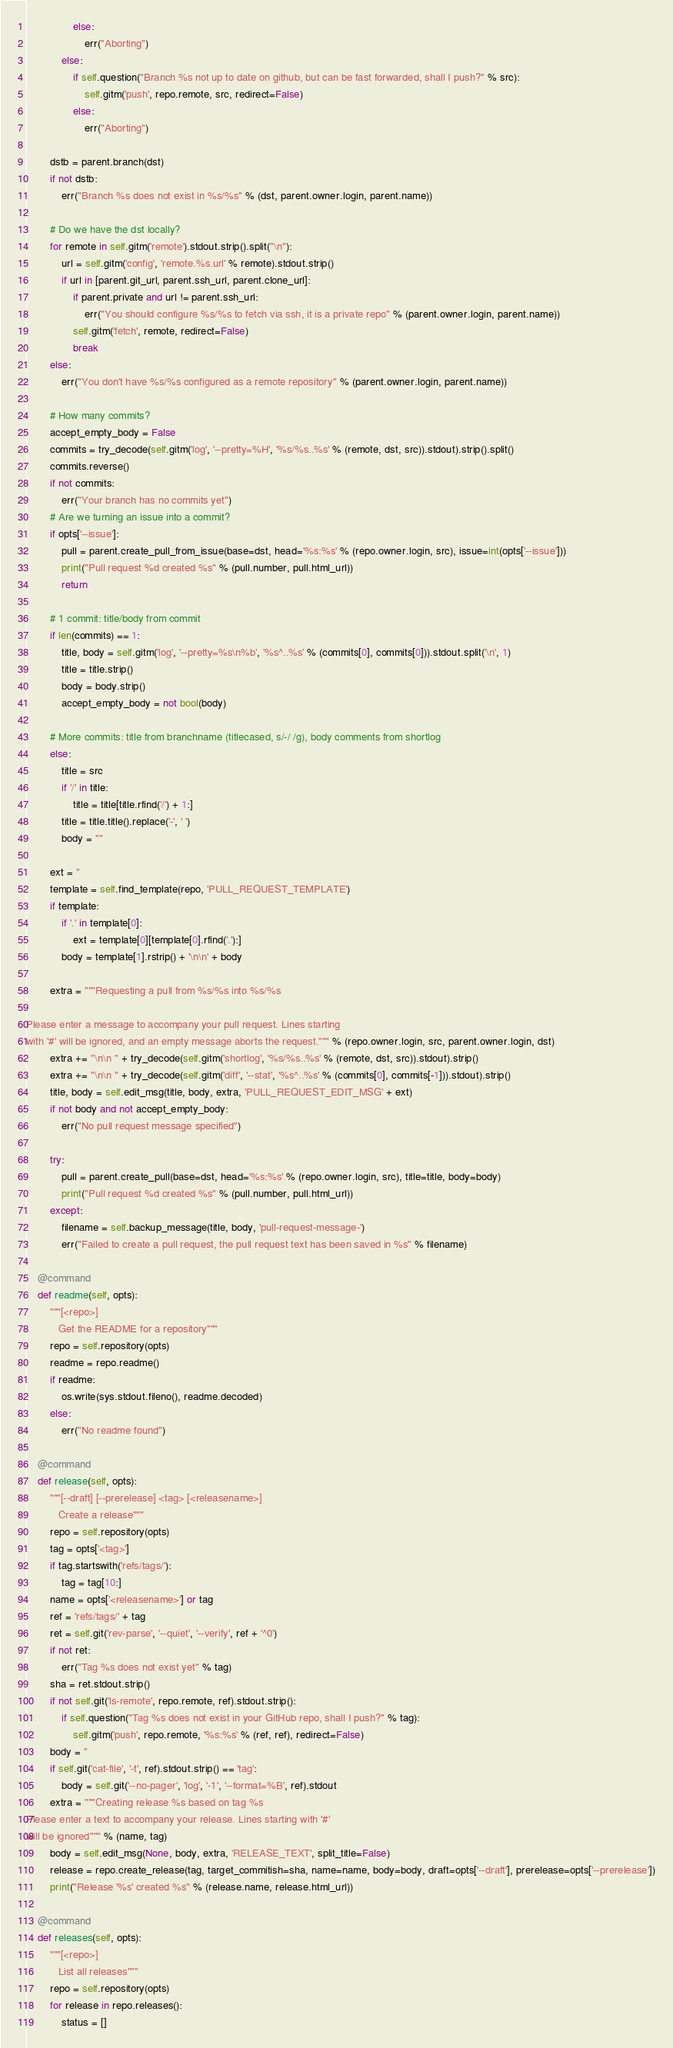<code> <loc_0><loc_0><loc_500><loc_500><_Python_>                else:
                    err("Aborting")
            else:
                if self.question("Branch %s not up to date on github, but can be fast forwarded, shall I push?" % src):
                    self.gitm('push', repo.remote, src, redirect=False)
                else:
                    err("Aborting")

        dstb = parent.branch(dst)
        if not dstb:
            err("Branch %s does not exist in %s/%s" % (dst, parent.owner.login, parent.name))

        # Do we have the dst locally?
        for remote in self.gitm('remote').stdout.strip().split("\n"):
            url = self.gitm('config', 'remote.%s.url' % remote).stdout.strip()
            if url in [parent.git_url, parent.ssh_url, parent.clone_url]:
                if parent.private and url != parent.ssh_url:
                    err("You should configure %s/%s to fetch via ssh, it is a private repo" % (parent.owner.login, parent.name))
                self.gitm('fetch', remote, redirect=False)
                break
        else:
            err("You don't have %s/%s configured as a remote repository" % (parent.owner.login, parent.name))

        # How many commits?
        accept_empty_body = False
        commits = try_decode(self.gitm('log', '--pretty=%H', '%s/%s..%s' % (remote, dst, src)).stdout).strip().split()
        commits.reverse()
        if not commits:
            err("Your branch has no commits yet")
        # Are we turning an issue into a commit?
        if opts['--issue']:
            pull = parent.create_pull_from_issue(base=dst, head='%s:%s' % (repo.owner.login, src), issue=int(opts['--issue']))
            print("Pull request %d created %s" % (pull.number, pull.html_url))
            return

        # 1 commit: title/body from commit
        if len(commits) == 1:
            title, body = self.gitm('log', '--pretty=%s\n%b', '%s^..%s' % (commits[0], commits[0])).stdout.split('\n', 1)
            title = title.strip()
            body = body.strip()
            accept_empty_body = not bool(body)

        # More commits: title from branchname (titlecased, s/-/ /g), body comments from shortlog
        else:
            title = src
            if '/' in title:
                title = title[title.rfind('/') + 1:]
            title = title.title().replace('-', ' ')
            body = ""

        ext = ''
        template = self.find_template(repo, 'PULL_REQUEST_TEMPLATE')
        if template:
            if '.' in template[0]:
                ext = template[0][template[0].rfind('.'):]
            body = template[1].rstrip() + '\n\n' + body

        extra = """Requesting a pull from %s/%s into %s/%s

Please enter a message to accompany your pull request. Lines starting
with '#' will be ignored, and an empty message aborts the request.""" % (repo.owner.login, src, parent.owner.login, dst)
        extra += "\n\n " + try_decode(self.gitm('shortlog', '%s/%s..%s' % (remote, dst, src)).stdout).strip()
        extra += "\n\n " + try_decode(self.gitm('diff', '--stat', '%s^..%s' % (commits[0], commits[-1])).stdout).strip()
        title, body = self.edit_msg(title, body, extra, 'PULL_REQUEST_EDIT_MSG' + ext)
        if not body and not accept_empty_body:
            err("No pull request message specified")

        try:
            pull = parent.create_pull(base=dst, head='%s:%s' % (repo.owner.login, src), title=title, body=body)
            print("Pull request %d created %s" % (pull.number, pull.html_url))
        except:
            filename = self.backup_message(title, body, 'pull-request-message-')
            err("Failed to create a pull request, the pull request text has been saved in %s" % filename)

    @command
    def readme(self, opts):
        """[<repo>]
           Get the README for a repository"""
        repo = self.repository(opts)
        readme = repo.readme()
        if readme:
            os.write(sys.stdout.fileno(), readme.decoded)
        else:
            err("No readme found")

    @command
    def release(self, opts):
        """[--draft] [--prerelease] <tag> [<releasename>]
           Create a release"""
        repo = self.repository(opts)
        tag = opts['<tag>']
        if tag.startswith('refs/tags/'):
            tag = tag[10:]
        name = opts['<releasename>'] or tag
        ref = 'refs/tags/' + tag
        ret = self.git('rev-parse', '--quiet', '--verify', ref + '^0')
        if not ret:
            err("Tag %s does not exist yet" % tag)
        sha = ret.stdout.strip()
        if not self.git('ls-remote', repo.remote, ref).stdout.strip():
            if self.question("Tag %s does not exist in your GitHub repo, shall I push?" % tag):
                self.gitm('push', repo.remote, '%s:%s' % (ref, ref), redirect=False)
        body = ''
        if self.git('cat-file', '-t', ref).stdout.strip() == 'tag':
            body = self.git('--no-pager', 'log', '-1', '--format=%B', ref).stdout
        extra = """Creating release %s based on tag %s
Please enter a text to accompany your release. Lines starting with '#'
will be ignored""" % (name, tag)
        body = self.edit_msg(None, body, extra, 'RELEASE_TEXT', split_title=False)
        release = repo.create_release(tag, target_commitish=sha, name=name, body=body, draft=opts['--draft'], prerelease=opts['--prerelease'])
        print("Release '%s' created %s" % (release.name, release.html_url))

    @command
    def releases(self, opts):
        """[<repo>]
           List all releases"""
        repo = self.repository(opts)
        for release in repo.releases():
            status = []</code> 